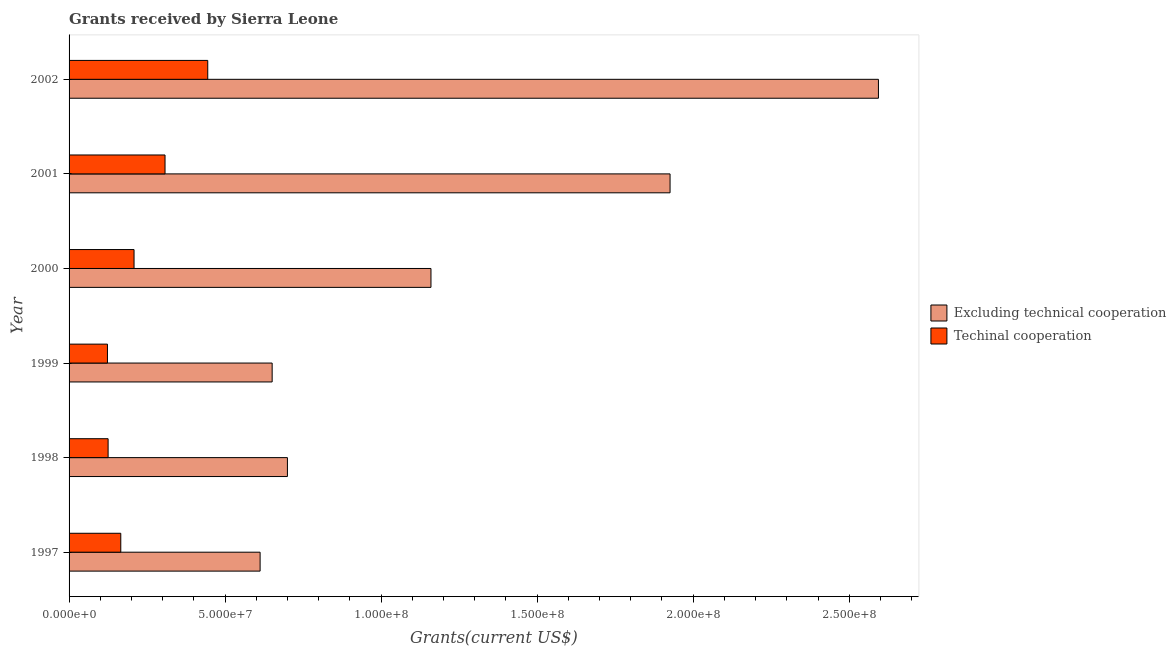How many different coloured bars are there?
Make the answer very short. 2. Are the number of bars per tick equal to the number of legend labels?
Offer a very short reply. Yes. How many bars are there on the 6th tick from the top?
Provide a succinct answer. 2. How many bars are there on the 6th tick from the bottom?
Your answer should be compact. 2. In how many cases, is the number of bars for a given year not equal to the number of legend labels?
Offer a terse response. 0. What is the amount of grants received(including technical cooperation) in 1998?
Your answer should be very brief. 1.25e+07. Across all years, what is the maximum amount of grants received(including technical cooperation)?
Your response must be concise. 4.44e+07. Across all years, what is the minimum amount of grants received(excluding technical cooperation)?
Offer a terse response. 6.12e+07. What is the total amount of grants received(including technical cooperation) in the graph?
Your answer should be very brief. 1.37e+08. What is the difference between the amount of grants received(excluding technical cooperation) in 1999 and that in 2002?
Your answer should be compact. -1.94e+08. What is the difference between the amount of grants received(excluding technical cooperation) in 1997 and the amount of grants received(including technical cooperation) in 1998?
Give a very brief answer. 4.87e+07. What is the average amount of grants received(excluding technical cooperation) per year?
Provide a short and direct response. 1.27e+08. In the year 1998, what is the difference between the amount of grants received(excluding technical cooperation) and amount of grants received(including technical cooperation)?
Your response must be concise. 5.75e+07. What is the ratio of the amount of grants received(including technical cooperation) in 1997 to that in 2000?
Give a very brief answer. 0.8. Is the difference between the amount of grants received(excluding technical cooperation) in 1999 and 2002 greater than the difference between the amount of grants received(including technical cooperation) in 1999 and 2002?
Provide a succinct answer. No. What is the difference between the highest and the second highest amount of grants received(including technical cooperation)?
Give a very brief answer. 1.37e+07. What is the difference between the highest and the lowest amount of grants received(excluding technical cooperation)?
Provide a short and direct response. 1.98e+08. In how many years, is the amount of grants received(including technical cooperation) greater than the average amount of grants received(including technical cooperation) taken over all years?
Your answer should be very brief. 2. What does the 2nd bar from the top in 1997 represents?
Your answer should be very brief. Excluding technical cooperation. What does the 2nd bar from the bottom in 1997 represents?
Offer a terse response. Techinal cooperation. How many bars are there?
Provide a short and direct response. 12. How many years are there in the graph?
Ensure brevity in your answer.  6. What is the difference between two consecutive major ticks on the X-axis?
Ensure brevity in your answer.  5.00e+07. Are the values on the major ticks of X-axis written in scientific E-notation?
Your answer should be compact. Yes. How many legend labels are there?
Your response must be concise. 2. What is the title of the graph?
Your response must be concise. Grants received by Sierra Leone. What is the label or title of the X-axis?
Ensure brevity in your answer.  Grants(current US$). What is the Grants(current US$) in Excluding technical cooperation in 1997?
Provide a short and direct response. 6.12e+07. What is the Grants(current US$) of Techinal cooperation in 1997?
Your answer should be compact. 1.66e+07. What is the Grants(current US$) of Excluding technical cooperation in 1998?
Your response must be concise. 7.00e+07. What is the Grants(current US$) in Techinal cooperation in 1998?
Provide a short and direct response. 1.25e+07. What is the Grants(current US$) in Excluding technical cooperation in 1999?
Offer a very short reply. 6.51e+07. What is the Grants(current US$) in Techinal cooperation in 1999?
Ensure brevity in your answer.  1.23e+07. What is the Grants(current US$) of Excluding technical cooperation in 2000?
Your answer should be very brief. 1.16e+08. What is the Grants(current US$) of Techinal cooperation in 2000?
Offer a terse response. 2.08e+07. What is the Grants(current US$) in Excluding technical cooperation in 2001?
Provide a succinct answer. 1.93e+08. What is the Grants(current US$) in Techinal cooperation in 2001?
Your answer should be very brief. 3.08e+07. What is the Grants(current US$) in Excluding technical cooperation in 2002?
Ensure brevity in your answer.  2.59e+08. What is the Grants(current US$) in Techinal cooperation in 2002?
Your response must be concise. 4.44e+07. Across all years, what is the maximum Grants(current US$) of Excluding technical cooperation?
Your response must be concise. 2.59e+08. Across all years, what is the maximum Grants(current US$) of Techinal cooperation?
Give a very brief answer. 4.44e+07. Across all years, what is the minimum Grants(current US$) in Excluding technical cooperation?
Make the answer very short. 6.12e+07. Across all years, what is the minimum Grants(current US$) in Techinal cooperation?
Offer a very short reply. 1.23e+07. What is the total Grants(current US$) of Excluding technical cooperation in the graph?
Offer a terse response. 7.64e+08. What is the total Grants(current US$) of Techinal cooperation in the graph?
Make the answer very short. 1.37e+08. What is the difference between the Grants(current US$) of Excluding technical cooperation in 1997 and that in 1998?
Make the answer very short. -8.75e+06. What is the difference between the Grants(current US$) in Techinal cooperation in 1997 and that in 1998?
Your response must be concise. 4.06e+06. What is the difference between the Grants(current US$) in Excluding technical cooperation in 1997 and that in 1999?
Offer a very short reply. -3.86e+06. What is the difference between the Grants(current US$) in Techinal cooperation in 1997 and that in 1999?
Ensure brevity in your answer.  4.27e+06. What is the difference between the Grants(current US$) in Excluding technical cooperation in 1997 and that in 2000?
Your answer should be very brief. -5.48e+07. What is the difference between the Grants(current US$) in Techinal cooperation in 1997 and that in 2000?
Your answer should be compact. -4.25e+06. What is the difference between the Grants(current US$) in Excluding technical cooperation in 1997 and that in 2001?
Your answer should be very brief. -1.31e+08. What is the difference between the Grants(current US$) in Techinal cooperation in 1997 and that in 2001?
Make the answer very short. -1.42e+07. What is the difference between the Grants(current US$) in Excluding technical cooperation in 1997 and that in 2002?
Ensure brevity in your answer.  -1.98e+08. What is the difference between the Grants(current US$) of Techinal cooperation in 1997 and that in 2002?
Make the answer very short. -2.79e+07. What is the difference between the Grants(current US$) in Excluding technical cooperation in 1998 and that in 1999?
Your response must be concise. 4.89e+06. What is the difference between the Grants(current US$) of Techinal cooperation in 1998 and that in 1999?
Give a very brief answer. 2.10e+05. What is the difference between the Grants(current US$) in Excluding technical cooperation in 1998 and that in 2000?
Keep it short and to the point. -4.60e+07. What is the difference between the Grants(current US$) of Techinal cooperation in 1998 and that in 2000?
Your response must be concise. -8.31e+06. What is the difference between the Grants(current US$) in Excluding technical cooperation in 1998 and that in 2001?
Keep it short and to the point. -1.23e+08. What is the difference between the Grants(current US$) in Techinal cooperation in 1998 and that in 2001?
Provide a short and direct response. -1.82e+07. What is the difference between the Grants(current US$) of Excluding technical cooperation in 1998 and that in 2002?
Provide a succinct answer. -1.89e+08. What is the difference between the Grants(current US$) of Techinal cooperation in 1998 and that in 2002?
Your response must be concise. -3.19e+07. What is the difference between the Grants(current US$) in Excluding technical cooperation in 1999 and that in 2000?
Make the answer very short. -5.09e+07. What is the difference between the Grants(current US$) in Techinal cooperation in 1999 and that in 2000?
Keep it short and to the point. -8.52e+06. What is the difference between the Grants(current US$) in Excluding technical cooperation in 1999 and that in 2001?
Provide a short and direct response. -1.28e+08. What is the difference between the Grants(current US$) of Techinal cooperation in 1999 and that in 2001?
Your answer should be compact. -1.84e+07. What is the difference between the Grants(current US$) of Excluding technical cooperation in 1999 and that in 2002?
Make the answer very short. -1.94e+08. What is the difference between the Grants(current US$) of Techinal cooperation in 1999 and that in 2002?
Provide a short and direct response. -3.21e+07. What is the difference between the Grants(current US$) of Excluding technical cooperation in 2000 and that in 2001?
Ensure brevity in your answer.  -7.66e+07. What is the difference between the Grants(current US$) in Techinal cooperation in 2000 and that in 2001?
Offer a very short reply. -9.93e+06. What is the difference between the Grants(current US$) of Excluding technical cooperation in 2000 and that in 2002?
Your answer should be very brief. -1.43e+08. What is the difference between the Grants(current US$) in Techinal cooperation in 2000 and that in 2002?
Offer a terse response. -2.36e+07. What is the difference between the Grants(current US$) of Excluding technical cooperation in 2001 and that in 2002?
Offer a terse response. -6.68e+07. What is the difference between the Grants(current US$) in Techinal cooperation in 2001 and that in 2002?
Your answer should be compact. -1.37e+07. What is the difference between the Grants(current US$) in Excluding technical cooperation in 1997 and the Grants(current US$) in Techinal cooperation in 1998?
Provide a short and direct response. 4.87e+07. What is the difference between the Grants(current US$) in Excluding technical cooperation in 1997 and the Grants(current US$) in Techinal cooperation in 1999?
Your response must be concise. 4.89e+07. What is the difference between the Grants(current US$) in Excluding technical cooperation in 1997 and the Grants(current US$) in Techinal cooperation in 2000?
Ensure brevity in your answer.  4.04e+07. What is the difference between the Grants(current US$) in Excluding technical cooperation in 1997 and the Grants(current US$) in Techinal cooperation in 2001?
Provide a succinct answer. 3.05e+07. What is the difference between the Grants(current US$) of Excluding technical cooperation in 1997 and the Grants(current US$) of Techinal cooperation in 2002?
Your response must be concise. 1.68e+07. What is the difference between the Grants(current US$) of Excluding technical cooperation in 1998 and the Grants(current US$) of Techinal cooperation in 1999?
Your response must be concise. 5.77e+07. What is the difference between the Grants(current US$) in Excluding technical cooperation in 1998 and the Grants(current US$) in Techinal cooperation in 2000?
Your answer should be very brief. 4.92e+07. What is the difference between the Grants(current US$) of Excluding technical cooperation in 1998 and the Grants(current US$) of Techinal cooperation in 2001?
Provide a short and direct response. 3.92e+07. What is the difference between the Grants(current US$) of Excluding technical cooperation in 1998 and the Grants(current US$) of Techinal cooperation in 2002?
Ensure brevity in your answer.  2.55e+07. What is the difference between the Grants(current US$) in Excluding technical cooperation in 1999 and the Grants(current US$) in Techinal cooperation in 2000?
Ensure brevity in your answer.  4.43e+07. What is the difference between the Grants(current US$) in Excluding technical cooperation in 1999 and the Grants(current US$) in Techinal cooperation in 2001?
Your response must be concise. 3.43e+07. What is the difference between the Grants(current US$) in Excluding technical cooperation in 1999 and the Grants(current US$) in Techinal cooperation in 2002?
Offer a terse response. 2.06e+07. What is the difference between the Grants(current US$) in Excluding technical cooperation in 2000 and the Grants(current US$) in Techinal cooperation in 2001?
Ensure brevity in your answer.  8.52e+07. What is the difference between the Grants(current US$) in Excluding technical cooperation in 2000 and the Grants(current US$) in Techinal cooperation in 2002?
Provide a succinct answer. 7.15e+07. What is the difference between the Grants(current US$) in Excluding technical cooperation in 2001 and the Grants(current US$) in Techinal cooperation in 2002?
Your response must be concise. 1.48e+08. What is the average Grants(current US$) of Excluding technical cooperation per year?
Provide a short and direct response. 1.27e+08. What is the average Grants(current US$) in Techinal cooperation per year?
Your response must be concise. 2.29e+07. In the year 1997, what is the difference between the Grants(current US$) of Excluding technical cooperation and Grants(current US$) of Techinal cooperation?
Your answer should be compact. 4.46e+07. In the year 1998, what is the difference between the Grants(current US$) of Excluding technical cooperation and Grants(current US$) of Techinal cooperation?
Offer a terse response. 5.75e+07. In the year 1999, what is the difference between the Grants(current US$) in Excluding technical cooperation and Grants(current US$) in Techinal cooperation?
Your answer should be compact. 5.28e+07. In the year 2000, what is the difference between the Grants(current US$) of Excluding technical cooperation and Grants(current US$) of Techinal cooperation?
Make the answer very short. 9.52e+07. In the year 2001, what is the difference between the Grants(current US$) of Excluding technical cooperation and Grants(current US$) of Techinal cooperation?
Offer a very short reply. 1.62e+08. In the year 2002, what is the difference between the Grants(current US$) of Excluding technical cooperation and Grants(current US$) of Techinal cooperation?
Your response must be concise. 2.15e+08. What is the ratio of the Grants(current US$) in Excluding technical cooperation in 1997 to that in 1998?
Your response must be concise. 0.87. What is the ratio of the Grants(current US$) in Techinal cooperation in 1997 to that in 1998?
Your answer should be very brief. 1.32. What is the ratio of the Grants(current US$) in Excluding technical cooperation in 1997 to that in 1999?
Offer a very short reply. 0.94. What is the ratio of the Grants(current US$) in Techinal cooperation in 1997 to that in 1999?
Offer a terse response. 1.35. What is the ratio of the Grants(current US$) in Excluding technical cooperation in 1997 to that in 2000?
Your answer should be compact. 0.53. What is the ratio of the Grants(current US$) in Techinal cooperation in 1997 to that in 2000?
Provide a short and direct response. 0.8. What is the ratio of the Grants(current US$) of Excluding technical cooperation in 1997 to that in 2001?
Your response must be concise. 0.32. What is the ratio of the Grants(current US$) in Techinal cooperation in 1997 to that in 2001?
Offer a very short reply. 0.54. What is the ratio of the Grants(current US$) in Excluding technical cooperation in 1997 to that in 2002?
Provide a short and direct response. 0.24. What is the ratio of the Grants(current US$) of Techinal cooperation in 1997 to that in 2002?
Make the answer very short. 0.37. What is the ratio of the Grants(current US$) in Excluding technical cooperation in 1998 to that in 1999?
Provide a short and direct response. 1.08. What is the ratio of the Grants(current US$) of Techinal cooperation in 1998 to that in 1999?
Your response must be concise. 1.02. What is the ratio of the Grants(current US$) in Excluding technical cooperation in 1998 to that in 2000?
Your answer should be very brief. 0.6. What is the ratio of the Grants(current US$) in Techinal cooperation in 1998 to that in 2000?
Provide a succinct answer. 0.6. What is the ratio of the Grants(current US$) of Excluding technical cooperation in 1998 to that in 2001?
Your answer should be compact. 0.36. What is the ratio of the Grants(current US$) of Techinal cooperation in 1998 to that in 2001?
Provide a succinct answer. 0.41. What is the ratio of the Grants(current US$) of Excluding technical cooperation in 1998 to that in 2002?
Provide a succinct answer. 0.27. What is the ratio of the Grants(current US$) of Techinal cooperation in 1998 to that in 2002?
Make the answer very short. 0.28. What is the ratio of the Grants(current US$) in Excluding technical cooperation in 1999 to that in 2000?
Your answer should be very brief. 0.56. What is the ratio of the Grants(current US$) of Techinal cooperation in 1999 to that in 2000?
Give a very brief answer. 0.59. What is the ratio of the Grants(current US$) of Excluding technical cooperation in 1999 to that in 2001?
Your answer should be very brief. 0.34. What is the ratio of the Grants(current US$) of Excluding technical cooperation in 1999 to that in 2002?
Your answer should be very brief. 0.25. What is the ratio of the Grants(current US$) in Techinal cooperation in 1999 to that in 2002?
Make the answer very short. 0.28. What is the ratio of the Grants(current US$) in Excluding technical cooperation in 2000 to that in 2001?
Offer a terse response. 0.6. What is the ratio of the Grants(current US$) of Techinal cooperation in 2000 to that in 2001?
Ensure brevity in your answer.  0.68. What is the ratio of the Grants(current US$) in Excluding technical cooperation in 2000 to that in 2002?
Offer a terse response. 0.45. What is the ratio of the Grants(current US$) of Techinal cooperation in 2000 to that in 2002?
Keep it short and to the point. 0.47. What is the ratio of the Grants(current US$) in Excluding technical cooperation in 2001 to that in 2002?
Offer a very short reply. 0.74. What is the ratio of the Grants(current US$) of Techinal cooperation in 2001 to that in 2002?
Ensure brevity in your answer.  0.69. What is the difference between the highest and the second highest Grants(current US$) in Excluding technical cooperation?
Offer a very short reply. 6.68e+07. What is the difference between the highest and the second highest Grants(current US$) in Techinal cooperation?
Ensure brevity in your answer.  1.37e+07. What is the difference between the highest and the lowest Grants(current US$) in Excluding technical cooperation?
Make the answer very short. 1.98e+08. What is the difference between the highest and the lowest Grants(current US$) in Techinal cooperation?
Make the answer very short. 3.21e+07. 